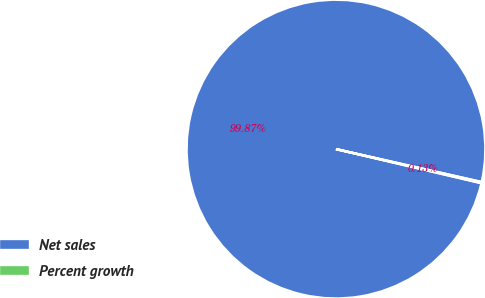Convert chart to OTSL. <chart><loc_0><loc_0><loc_500><loc_500><pie_chart><fcel>Net sales<fcel>Percent growth<nl><fcel>99.87%<fcel>0.13%<nl></chart> 